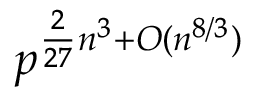Convert formula to latex. <formula><loc_0><loc_0><loc_500><loc_500>p ^ { { \frac { 2 } { 2 7 } } n ^ { 3 } + O ( n ^ { 8 / 3 } ) }</formula> 